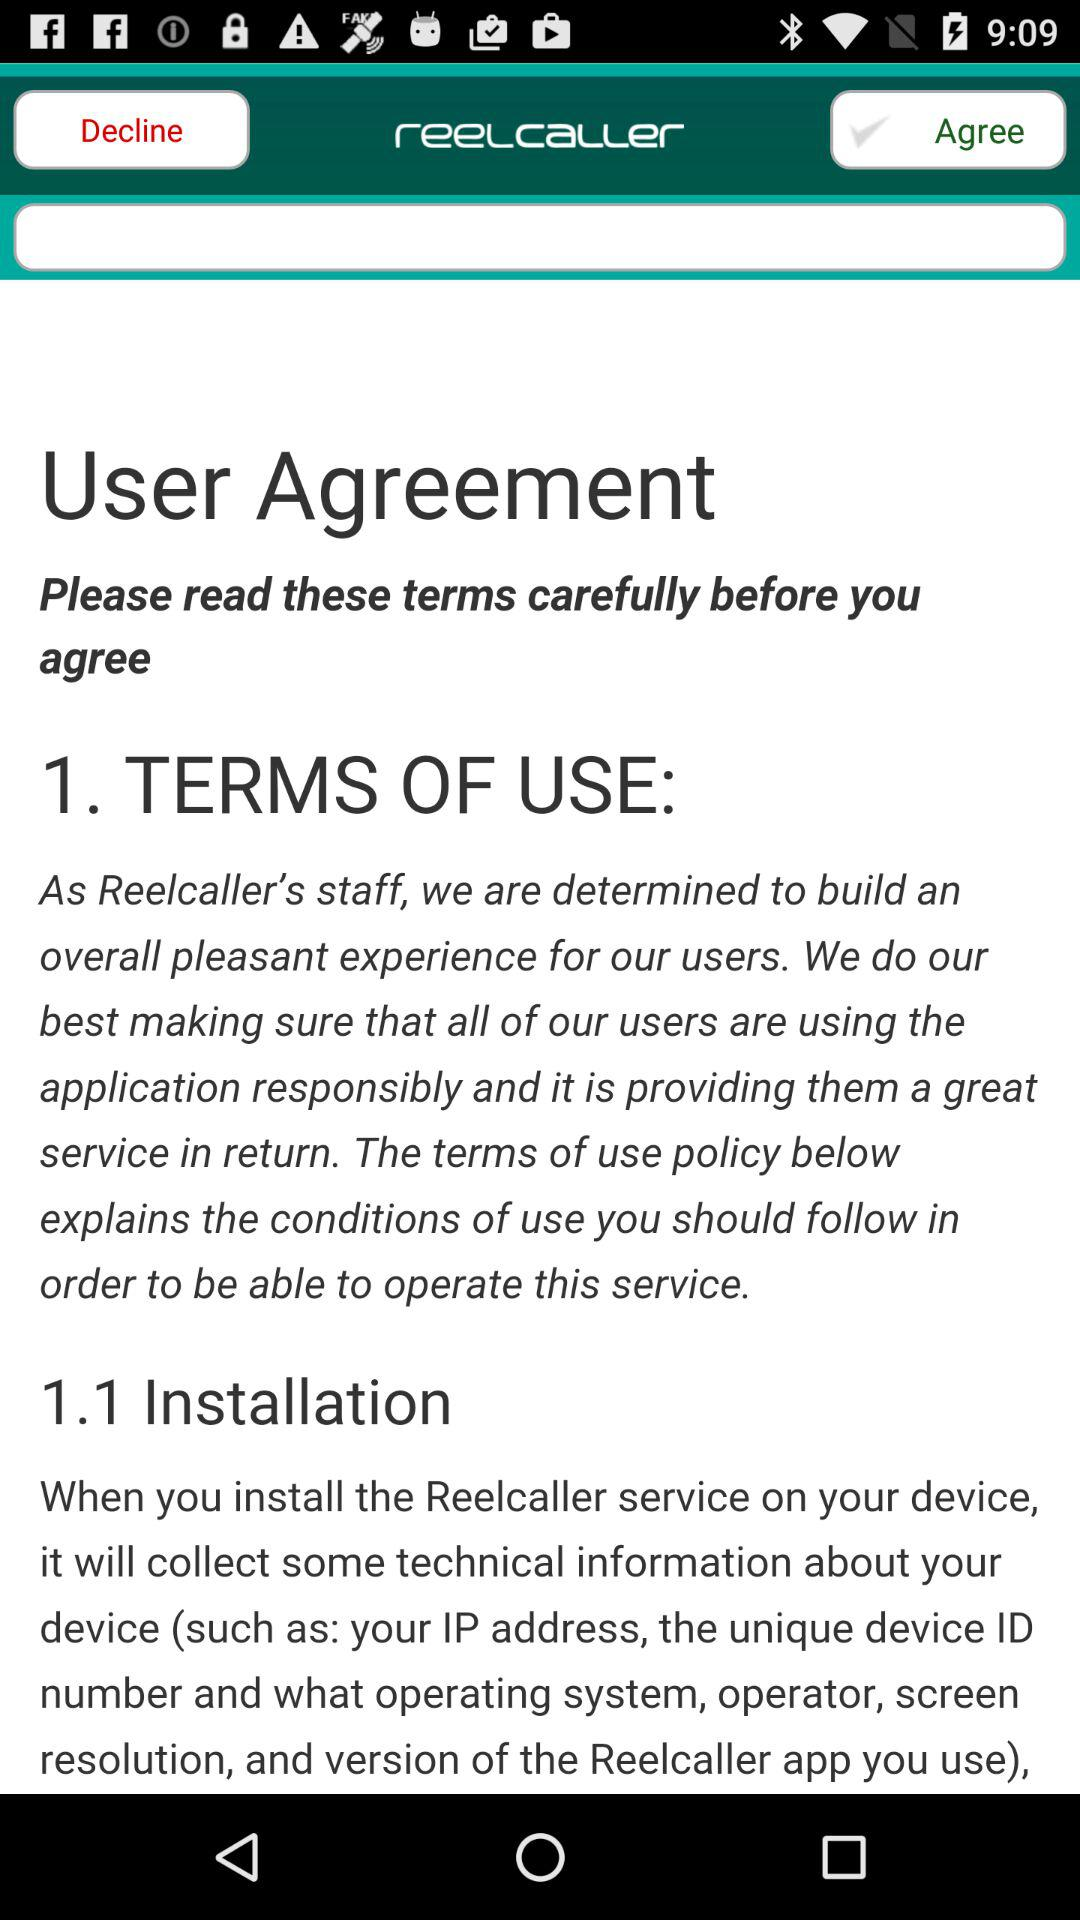What is the application name? The application name is "reelcaller". 